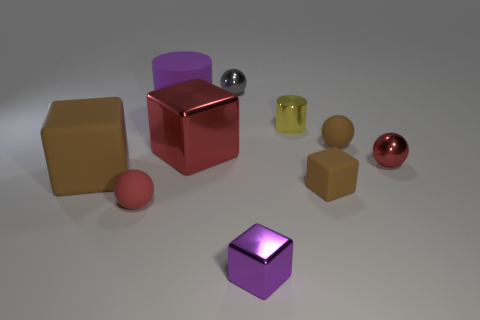What number of other things are the same color as the large cylinder?
Keep it short and to the point. 1. There is a large object that is the same color as the tiny matte cube; what shape is it?
Give a very brief answer. Cube. There is a purple matte thing behind the shiny object that is on the right side of the yellow metallic cylinder; what is its size?
Ensure brevity in your answer.  Large. How many cyan things are matte blocks or cylinders?
Your answer should be very brief. 0. Are there fewer big red objects that are behind the large cylinder than matte objects to the right of the red metal block?
Provide a short and direct response. Yes. There is a red metal cube; is it the same size as the brown thing that is on the left side of the big matte cylinder?
Give a very brief answer. Yes. What number of yellow things are the same size as the brown matte ball?
Ensure brevity in your answer.  1. What number of large objects are either yellow cylinders or brown blocks?
Your answer should be very brief. 1. Are there any big red metal cubes?
Keep it short and to the point. Yes. Are there more small metallic cylinders that are in front of the yellow object than metallic balls in front of the tiny red matte thing?
Keep it short and to the point. No. 